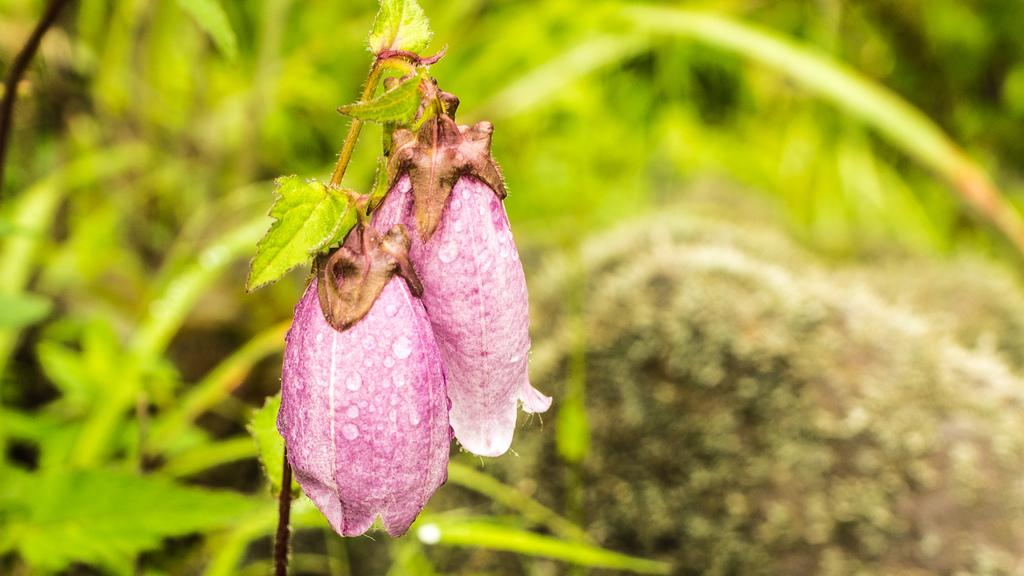What is the main subject of the image? There is a plant in the image. How many flowers are on the plant? Two flowers are present on the plant. What color are the flowers? The flowers are pink in color. Can you describe the background of the image? The background of the image is blurred. What type of beginner's cake can be seen in the image? There is no cake present in the image; it features a plant with two pink flowers. What is the chance of finding a hidden object in the blurred background of the image? There is no information about a hidden object in the image, and the blurred background does not imply the presence of any hidden elements. 